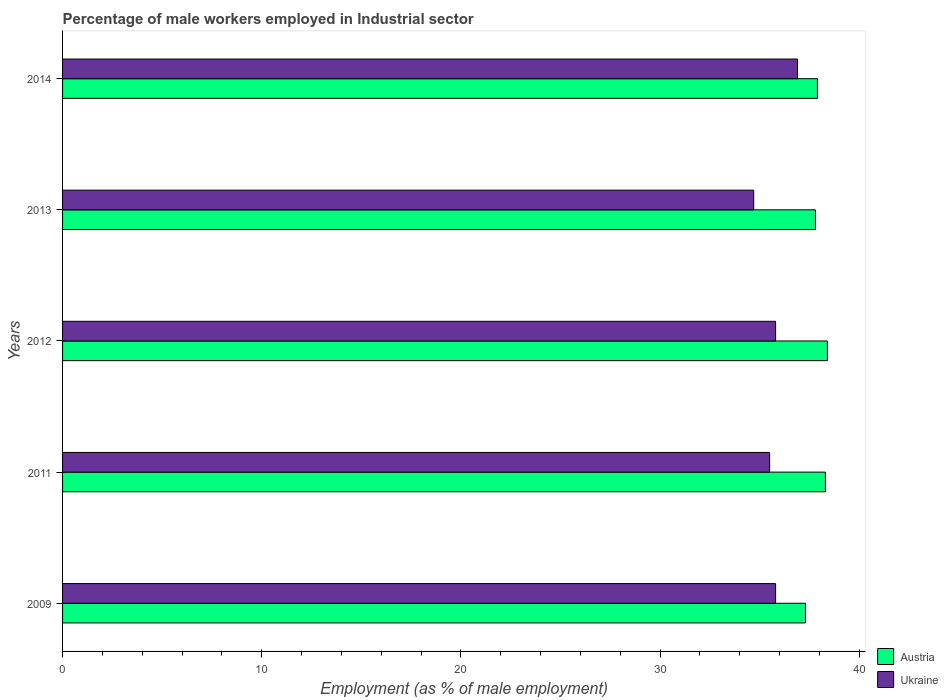How many different coloured bars are there?
Provide a succinct answer. 2. Are the number of bars on each tick of the Y-axis equal?
Your answer should be very brief. Yes. How many bars are there on the 3rd tick from the bottom?
Offer a very short reply. 2. What is the percentage of male workers employed in Industrial sector in Austria in 2012?
Offer a terse response. 38.4. Across all years, what is the maximum percentage of male workers employed in Industrial sector in Austria?
Keep it short and to the point. 38.4. Across all years, what is the minimum percentage of male workers employed in Industrial sector in Austria?
Provide a short and direct response. 37.3. In which year was the percentage of male workers employed in Industrial sector in Ukraine maximum?
Ensure brevity in your answer.  2014. In which year was the percentage of male workers employed in Industrial sector in Ukraine minimum?
Your response must be concise. 2013. What is the total percentage of male workers employed in Industrial sector in Ukraine in the graph?
Give a very brief answer. 178.7. What is the difference between the percentage of male workers employed in Industrial sector in Austria in 2012 and that in 2014?
Ensure brevity in your answer.  0.5. What is the difference between the percentage of male workers employed in Industrial sector in Austria in 2011 and the percentage of male workers employed in Industrial sector in Ukraine in 2013?
Offer a terse response. 3.6. What is the average percentage of male workers employed in Industrial sector in Austria per year?
Provide a succinct answer. 37.94. In the year 2014, what is the difference between the percentage of male workers employed in Industrial sector in Ukraine and percentage of male workers employed in Industrial sector in Austria?
Make the answer very short. -1. What is the ratio of the percentage of male workers employed in Industrial sector in Austria in 2009 to that in 2011?
Your answer should be very brief. 0.97. What is the difference between the highest and the second highest percentage of male workers employed in Industrial sector in Austria?
Provide a succinct answer. 0.1. What is the difference between the highest and the lowest percentage of male workers employed in Industrial sector in Ukraine?
Your response must be concise. 2.2. Is the sum of the percentage of male workers employed in Industrial sector in Ukraine in 2011 and 2014 greater than the maximum percentage of male workers employed in Industrial sector in Austria across all years?
Your answer should be very brief. Yes. What does the 1st bar from the top in 2011 represents?
Offer a very short reply. Ukraine. What does the 2nd bar from the bottom in 2013 represents?
Your answer should be compact. Ukraine. How many years are there in the graph?
Your answer should be compact. 5. What is the difference between two consecutive major ticks on the X-axis?
Provide a short and direct response. 10. Are the values on the major ticks of X-axis written in scientific E-notation?
Make the answer very short. No. Where does the legend appear in the graph?
Offer a very short reply. Bottom right. How many legend labels are there?
Your answer should be very brief. 2. How are the legend labels stacked?
Keep it short and to the point. Vertical. What is the title of the graph?
Ensure brevity in your answer.  Percentage of male workers employed in Industrial sector. What is the label or title of the X-axis?
Offer a very short reply. Employment (as % of male employment). What is the label or title of the Y-axis?
Provide a succinct answer. Years. What is the Employment (as % of male employment) of Austria in 2009?
Give a very brief answer. 37.3. What is the Employment (as % of male employment) in Ukraine in 2009?
Your answer should be very brief. 35.8. What is the Employment (as % of male employment) in Austria in 2011?
Keep it short and to the point. 38.3. What is the Employment (as % of male employment) in Ukraine in 2011?
Your response must be concise. 35.5. What is the Employment (as % of male employment) of Austria in 2012?
Your answer should be compact. 38.4. What is the Employment (as % of male employment) of Ukraine in 2012?
Keep it short and to the point. 35.8. What is the Employment (as % of male employment) of Austria in 2013?
Give a very brief answer. 37.8. What is the Employment (as % of male employment) in Ukraine in 2013?
Provide a short and direct response. 34.7. What is the Employment (as % of male employment) in Austria in 2014?
Your answer should be compact. 37.9. What is the Employment (as % of male employment) of Ukraine in 2014?
Give a very brief answer. 36.9. Across all years, what is the maximum Employment (as % of male employment) in Austria?
Offer a very short reply. 38.4. Across all years, what is the maximum Employment (as % of male employment) of Ukraine?
Ensure brevity in your answer.  36.9. Across all years, what is the minimum Employment (as % of male employment) in Austria?
Ensure brevity in your answer.  37.3. Across all years, what is the minimum Employment (as % of male employment) in Ukraine?
Offer a very short reply. 34.7. What is the total Employment (as % of male employment) of Austria in the graph?
Your answer should be compact. 189.7. What is the total Employment (as % of male employment) of Ukraine in the graph?
Provide a succinct answer. 178.7. What is the difference between the Employment (as % of male employment) in Austria in 2009 and that in 2011?
Your answer should be very brief. -1. What is the difference between the Employment (as % of male employment) of Austria in 2009 and that in 2012?
Provide a short and direct response. -1.1. What is the difference between the Employment (as % of male employment) of Ukraine in 2011 and that in 2012?
Keep it short and to the point. -0.3. What is the difference between the Employment (as % of male employment) of Ukraine in 2011 and that in 2013?
Your response must be concise. 0.8. What is the difference between the Employment (as % of male employment) of Ukraine in 2011 and that in 2014?
Your answer should be compact. -1.4. What is the difference between the Employment (as % of male employment) of Austria in 2012 and that in 2013?
Ensure brevity in your answer.  0.6. What is the difference between the Employment (as % of male employment) of Ukraine in 2012 and that in 2014?
Give a very brief answer. -1.1. What is the difference between the Employment (as % of male employment) in Austria in 2013 and that in 2014?
Keep it short and to the point. -0.1. What is the difference between the Employment (as % of male employment) of Austria in 2009 and the Employment (as % of male employment) of Ukraine in 2011?
Give a very brief answer. 1.8. What is the difference between the Employment (as % of male employment) in Austria in 2009 and the Employment (as % of male employment) in Ukraine in 2013?
Offer a very short reply. 2.6. What is the difference between the Employment (as % of male employment) in Austria in 2009 and the Employment (as % of male employment) in Ukraine in 2014?
Offer a very short reply. 0.4. What is the difference between the Employment (as % of male employment) in Austria in 2011 and the Employment (as % of male employment) in Ukraine in 2012?
Make the answer very short. 2.5. What is the difference between the Employment (as % of male employment) in Austria in 2011 and the Employment (as % of male employment) in Ukraine in 2014?
Your response must be concise. 1.4. What is the difference between the Employment (as % of male employment) in Austria in 2012 and the Employment (as % of male employment) in Ukraine in 2014?
Offer a very short reply. 1.5. What is the average Employment (as % of male employment) in Austria per year?
Keep it short and to the point. 37.94. What is the average Employment (as % of male employment) of Ukraine per year?
Your answer should be very brief. 35.74. In the year 2011, what is the difference between the Employment (as % of male employment) of Austria and Employment (as % of male employment) of Ukraine?
Keep it short and to the point. 2.8. What is the ratio of the Employment (as % of male employment) in Austria in 2009 to that in 2011?
Give a very brief answer. 0.97. What is the ratio of the Employment (as % of male employment) in Ukraine in 2009 to that in 2011?
Your answer should be very brief. 1.01. What is the ratio of the Employment (as % of male employment) of Austria in 2009 to that in 2012?
Your response must be concise. 0.97. What is the ratio of the Employment (as % of male employment) in Ukraine in 2009 to that in 2013?
Ensure brevity in your answer.  1.03. What is the ratio of the Employment (as % of male employment) in Austria in 2009 to that in 2014?
Ensure brevity in your answer.  0.98. What is the ratio of the Employment (as % of male employment) of Ukraine in 2009 to that in 2014?
Your answer should be very brief. 0.97. What is the ratio of the Employment (as % of male employment) of Austria in 2011 to that in 2013?
Ensure brevity in your answer.  1.01. What is the ratio of the Employment (as % of male employment) in Ukraine in 2011 to that in 2013?
Ensure brevity in your answer.  1.02. What is the ratio of the Employment (as % of male employment) of Austria in 2011 to that in 2014?
Provide a short and direct response. 1.01. What is the ratio of the Employment (as % of male employment) of Ukraine in 2011 to that in 2014?
Give a very brief answer. 0.96. What is the ratio of the Employment (as % of male employment) in Austria in 2012 to that in 2013?
Offer a very short reply. 1.02. What is the ratio of the Employment (as % of male employment) of Ukraine in 2012 to that in 2013?
Ensure brevity in your answer.  1.03. What is the ratio of the Employment (as % of male employment) of Austria in 2012 to that in 2014?
Offer a terse response. 1.01. What is the ratio of the Employment (as % of male employment) of Ukraine in 2012 to that in 2014?
Keep it short and to the point. 0.97. What is the ratio of the Employment (as % of male employment) in Austria in 2013 to that in 2014?
Your response must be concise. 1. What is the ratio of the Employment (as % of male employment) of Ukraine in 2013 to that in 2014?
Provide a short and direct response. 0.94. What is the difference between the highest and the second highest Employment (as % of male employment) of Austria?
Provide a short and direct response. 0.1. What is the difference between the highest and the second highest Employment (as % of male employment) of Ukraine?
Offer a very short reply. 1.1. What is the difference between the highest and the lowest Employment (as % of male employment) in Ukraine?
Offer a terse response. 2.2. 